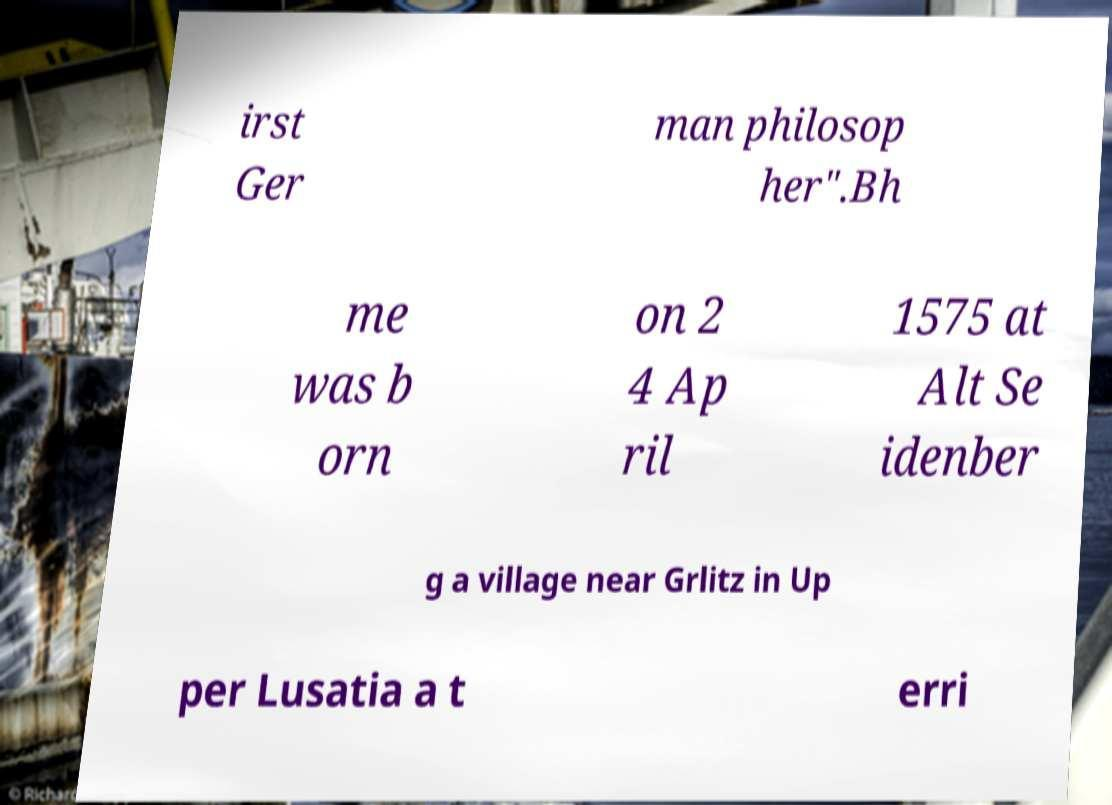There's text embedded in this image that I need extracted. Can you transcribe it verbatim? irst Ger man philosop her".Bh me was b orn on 2 4 Ap ril 1575 at Alt Se idenber g a village near Grlitz in Up per Lusatia a t erri 